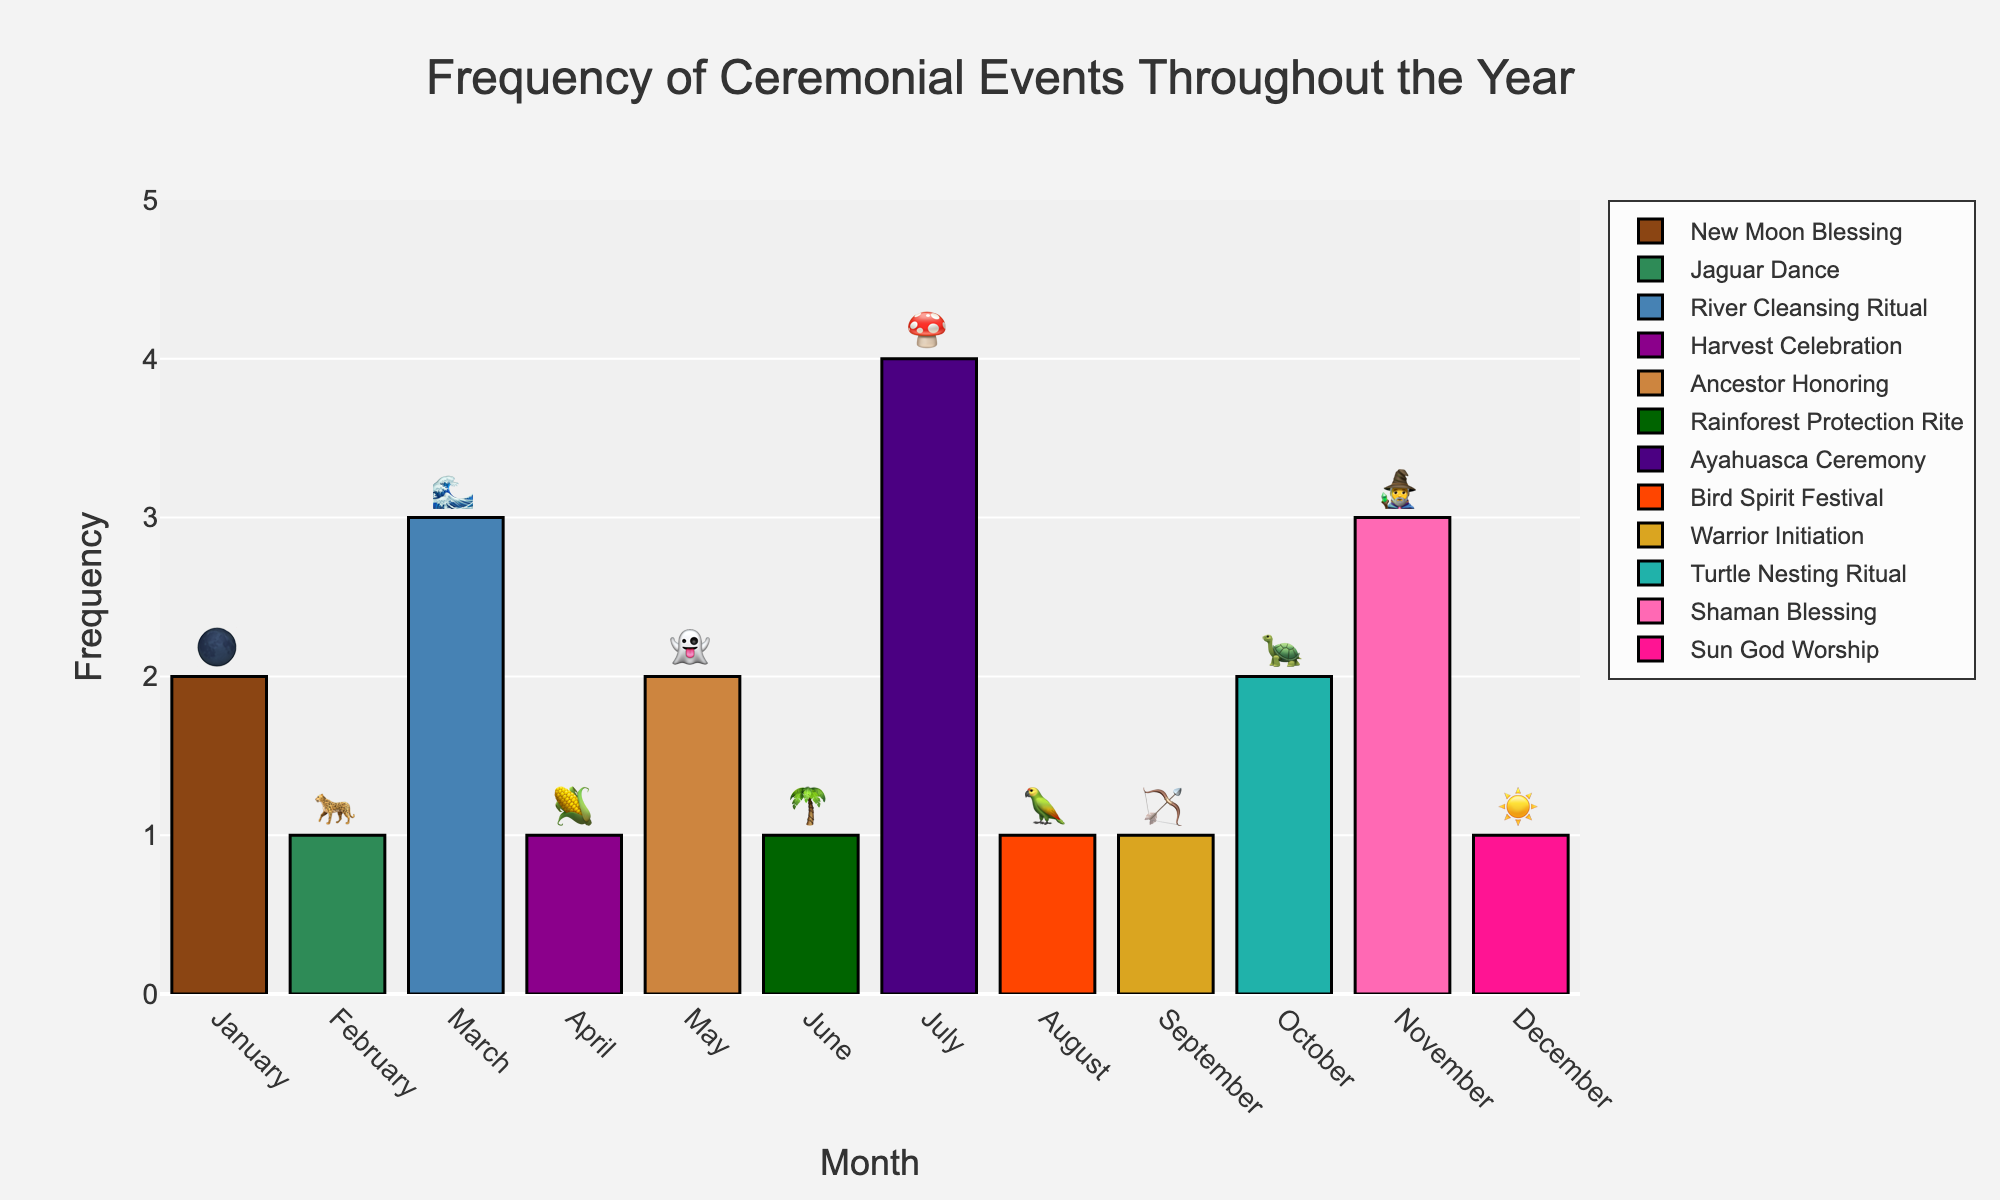Which month has the highest frequency of ceremonial events? By looking at the highest bar in the chart, it corresponds to the month of July.
Answer: July How many ceremonies occur in March? Refer to the figure and identify the bar for March, which shows a frequency of 3.
Answer: 3 What is the total sum of ceremonial events in January and February? Sum the frequencies for January (2) and February (1): 2 + 1 = 3.
Answer: 3 Is the frequency of "Ancestor Honoring" in May higher than the "Sun God Worship" in December? Check the figure for the bars corresponding to May (2) and December (1), and compare: 2 is greater than 1.
Answer: Yes What emojis represent the ceremonies in March and August? Locate March (🌊) and August (🦜) on the figure based on the text labels.
Answer: 🌊 and 🦜 Which ceremony has a frequency of four, and in which month does it occur? Identify the bar with a frequency of 4, which is in July and represents the Ayahuasca Ceremony.
Answer: Ayahuasca Ceremony in July What is the average frequency of ceremonial events in September and October? Calculate the average: (1 for September + 2 for October) / 2 = 1.5.
Answer: 1.5 Which ceremony occurs in June and how many times does it happen? Look for June on the figure, which is the Rainforest Protection Rite occurring once.
Answer: Rainforest Protection Rite, 1 How many more times does the "Shaman Blessing" in November occur compared to the "Jaguar Dance" in February? Subtract the frequency of February (1) from November (3): 3 - 1 = 2.
Answer: 2 Which month has both the "Harvest Celebration" and also the lowest frequency of ceremonies? Harvest Celebration is in April with a frequency of 1, the same as the lowest frequency.
Answer: April 